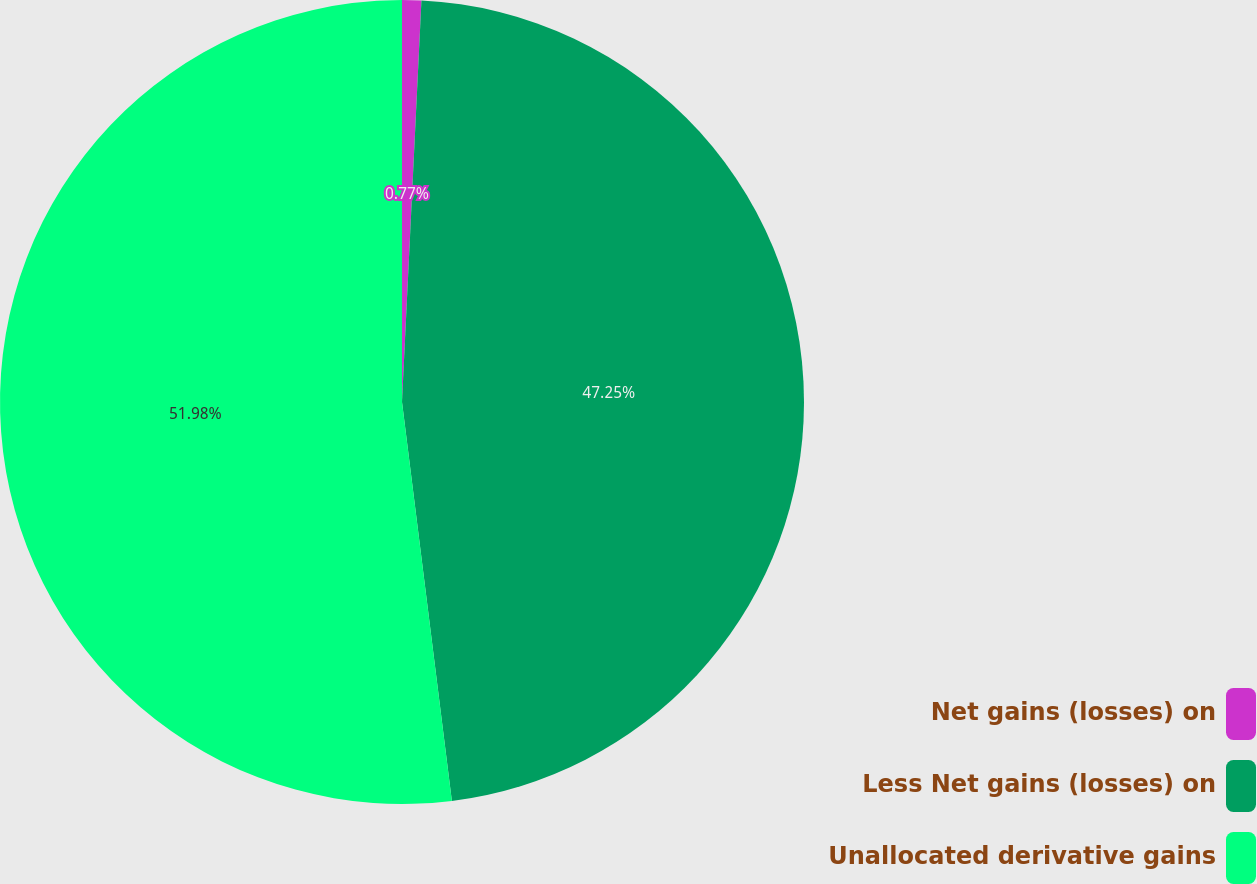Convert chart to OTSL. <chart><loc_0><loc_0><loc_500><loc_500><pie_chart><fcel>Net gains (losses) on<fcel>Less Net gains (losses) on<fcel>Unallocated derivative gains<nl><fcel>0.77%<fcel>47.25%<fcel>51.98%<nl></chart> 